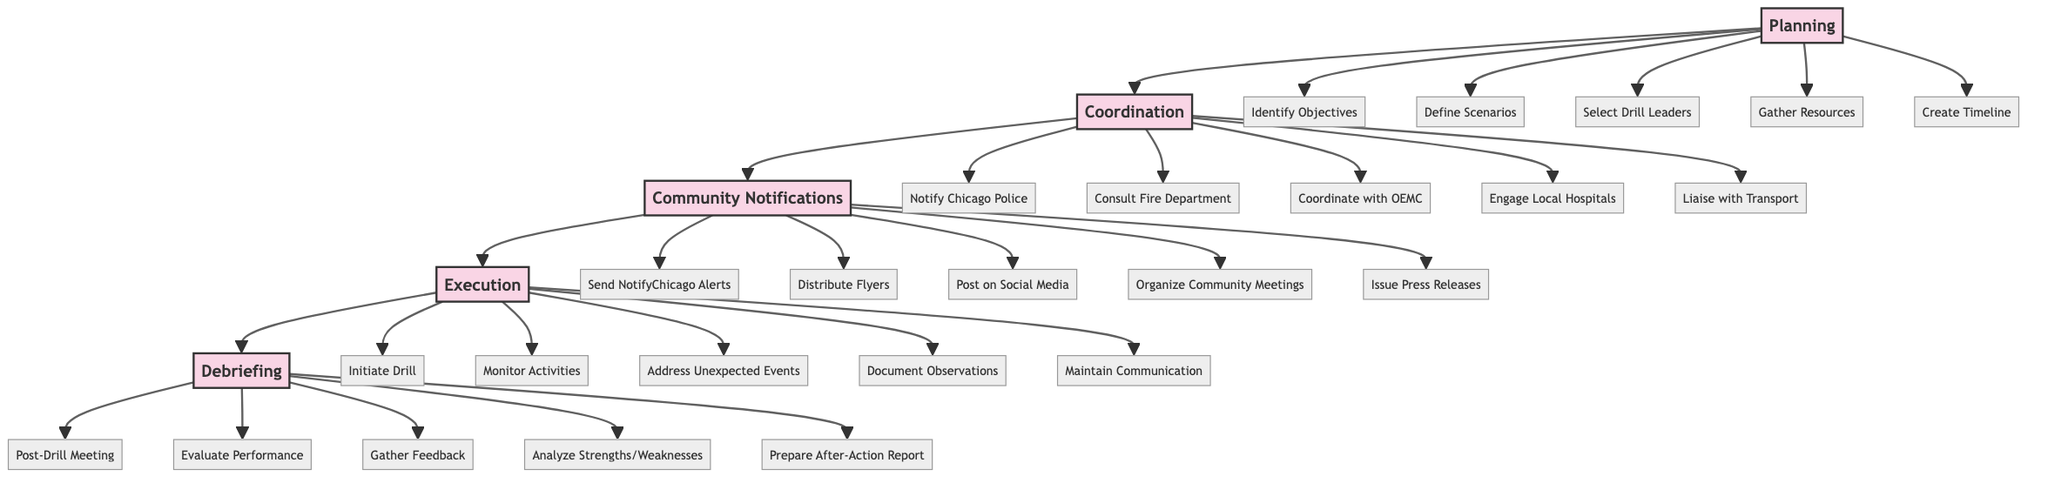What is the first step in the Emergency Preparedness Drill Procedures? The diagram starts with "Planning" as the initial step in the sequence of the Emergency Preparedness Drill Procedures.
Answer: Planning How many tasks are there in the "Planning" step? The "Planning" step includes five tasks: Identify Objectives, Define Scenarios, Select Drill Leaders, Gather Resources, and Create Timeline. Therefore, the total number of tasks is five.
Answer: 5 What comes after "Coordination with Emergency Services"? The next step following "Coordination with Emergency Services" is "Community Notifications," as indicated by the flow direction in the diagram.
Answer: Community Notifications How many tasks are listed under "Execution"? Under the "Execution" step, there are five tasks: Initiate Drill, Monitor Activities, Address Unexpected Events, Document Observations, and Maintain Communication Channels. So, there are five tasks in total.
Answer: 5 Which department do we notify first in the Coordination step? According to the diagram, the first task listed under "Coordination with Emergency Services" is to "Notify Chicago Police Department," indicating it is the first department to be notified.
Answer: Notify Chicago Police Department What is the last step in the Emergency Preparedness Drill Procedures? Looking at the flow chart, the last step in the sequence is "Debriefing," which follows all the previous steps and tasks.
Answer: Debriefing What is the primary purpose of the "Debriefing" step? The "Debriefing" step includes tasks aimed at evaluating the drill's performance and gathering insights, culminating in the preparation of an After-Action Report, which summarizes findings and lessons learned.
Answer: Evaluate Performance How many tasks are involved in "Community Notifications"? The "Community Notifications" step has five distinct tasks: Send Alerts via NotifyChicago, Distribute Flyers in Key Areas, Post Updates on Social Media, Organize Community Meetings, and Issue Press Releases, totaling to five.
Answer: 5 What do we do right after "Initiate Drill"? The next task that follows "Initiate Drill" in the "Execution" step is "Monitor Activities," indicating this is the immediate action to follow the initiation of the drill.
Answer: Monitor Activities 